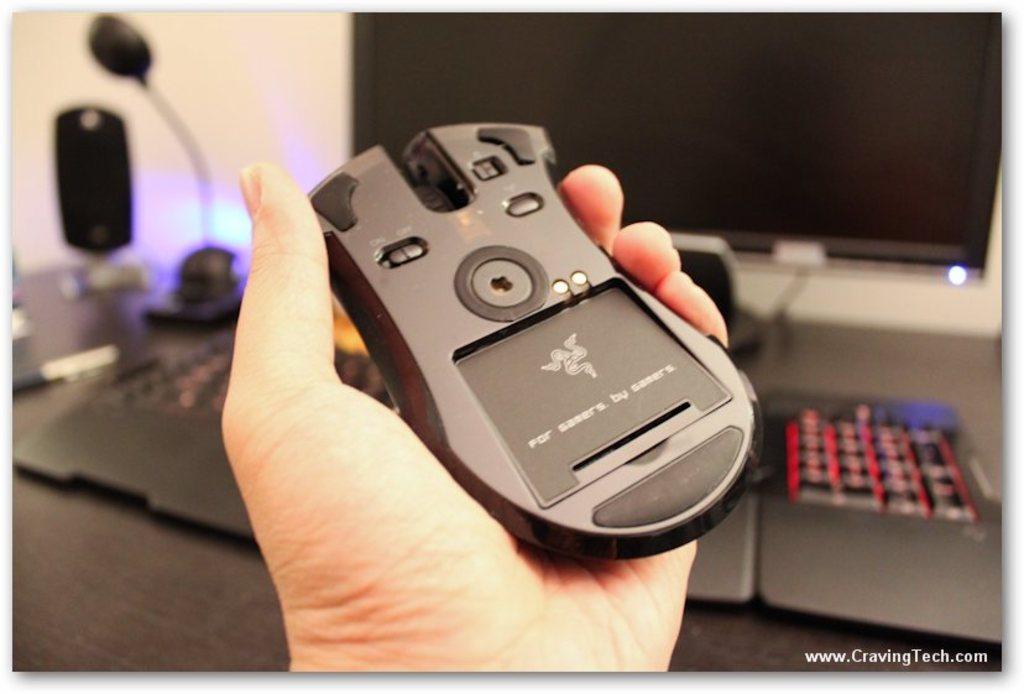In one or two sentences, can you explain what this image depicts? In the center of the image there is a mouse in a hand. In the background there is a monitor, keyboard, light, speaker, pen and wall. 